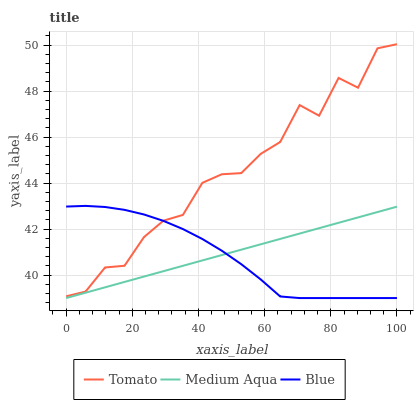Does Medium Aqua have the minimum area under the curve?
Answer yes or no. No. Does Medium Aqua have the maximum area under the curve?
Answer yes or no. No. Is Blue the smoothest?
Answer yes or no. No. Is Blue the roughest?
Answer yes or no. No. Does Blue have the highest value?
Answer yes or no. No. Is Medium Aqua less than Tomato?
Answer yes or no. Yes. Is Tomato greater than Medium Aqua?
Answer yes or no. Yes. Does Medium Aqua intersect Tomato?
Answer yes or no. No. 